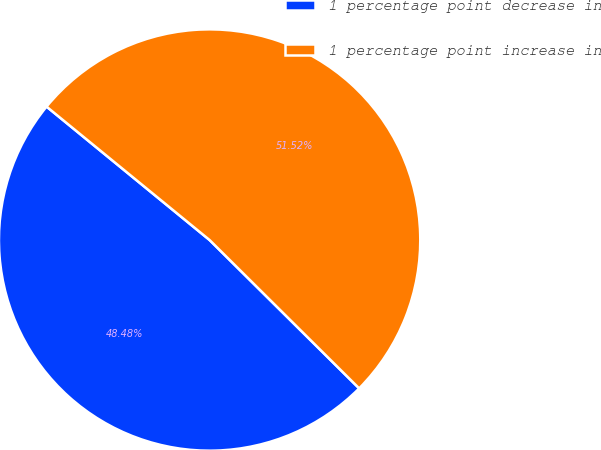Convert chart to OTSL. <chart><loc_0><loc_0><loc_500><loc_500><pie_chart><fcel>1 percentage point decrease in<fcel>1 percentage point increase in<nl><fcel>48.48%<fcel>51.52%<nl></chart> 